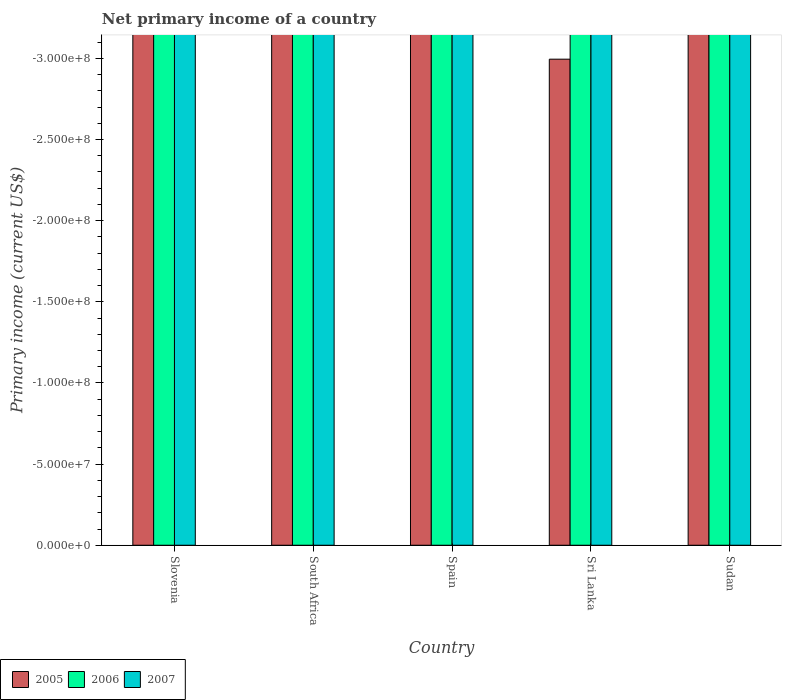How many bars are there on the 3rd tick from the right?
Provide a succinct answer. 0. What is the label of the 4th group of bars from the left?
Provide a succinct answer. Sri Lanka. In how many cases, is the number of bars for a given country not equal to the number of legend labels?
Offer a very short reply. 5. Across all countries, what is the minimum primary income in 2006?
Provide a succinct answer. 0. What is the difference between the primary income in 2007 in Spain and the primary income in 2005 in Slovenia?
Offer a very short reply. 0. In how many countries, is the primary income in 2005 greater than -150000000 US$?
Give a very brief answer. 0. In how many countries, is the primary income in 2006 greater than the average primary income in 2006 taken over all countries?
Keep it short and to the point. 0. How many bars are there?
Provide a short and direct response. 0. Are all the bars in the graph horizontal?
Keep it short and to the point. No. How many countries are there in the graph?
Make the answer very short. 5. What is the difference between two consecutive major ticks on the Y-axis?
Offer a terse response. 5.00e+07. Does the graph contain any zero values?
Give a very brief answer. Yes. Does the graph contain grids?
Your answer should be very brief. No. How many legend labels are there?
Offer a very short reply. 3. How are the legend labels stacked?
Ensure brevity in your answer.  Horizontal. What is the title of the graph?
Give a very brief answer. Net primary income of a country. What is the label or title of the Y-axis?
Make the answer very short. Primary income (current US$). What is the Primary income (current US$) of 2005 in Slovenia?
Keep it short and to the point. 0. What is the Primary income (current US$) in 2007 in Slovenia?
Keep it short and to the point. 0. What is the Primary income (current US$) in 2006 in South Africa?
Give a very brief answer. 0. What is the Primary income (current US$) of 2005 in Spain?
Provide a succinct answer. 0. What is the Primary income (current US$) in 2007 in Spain?
Give a very brief answer. 0. What is the Primary income (current US$) of 2005 in Sri Lanka?
Keep it short and to the point. 0. What is the Primary income (current US$) of 2006 in Sri Lanka?
Your answer should be very brief. 0. What is the Primary income (current US$) of 2005 in Sudan?
Your response must be concise. 0. What is the total Primary income (current US$) in 2006 in the graph?
Your answer should be compact. 0. What is the total Primary income (current US$) in 2007 in the graph?
Your answer should be very brief. 0. 